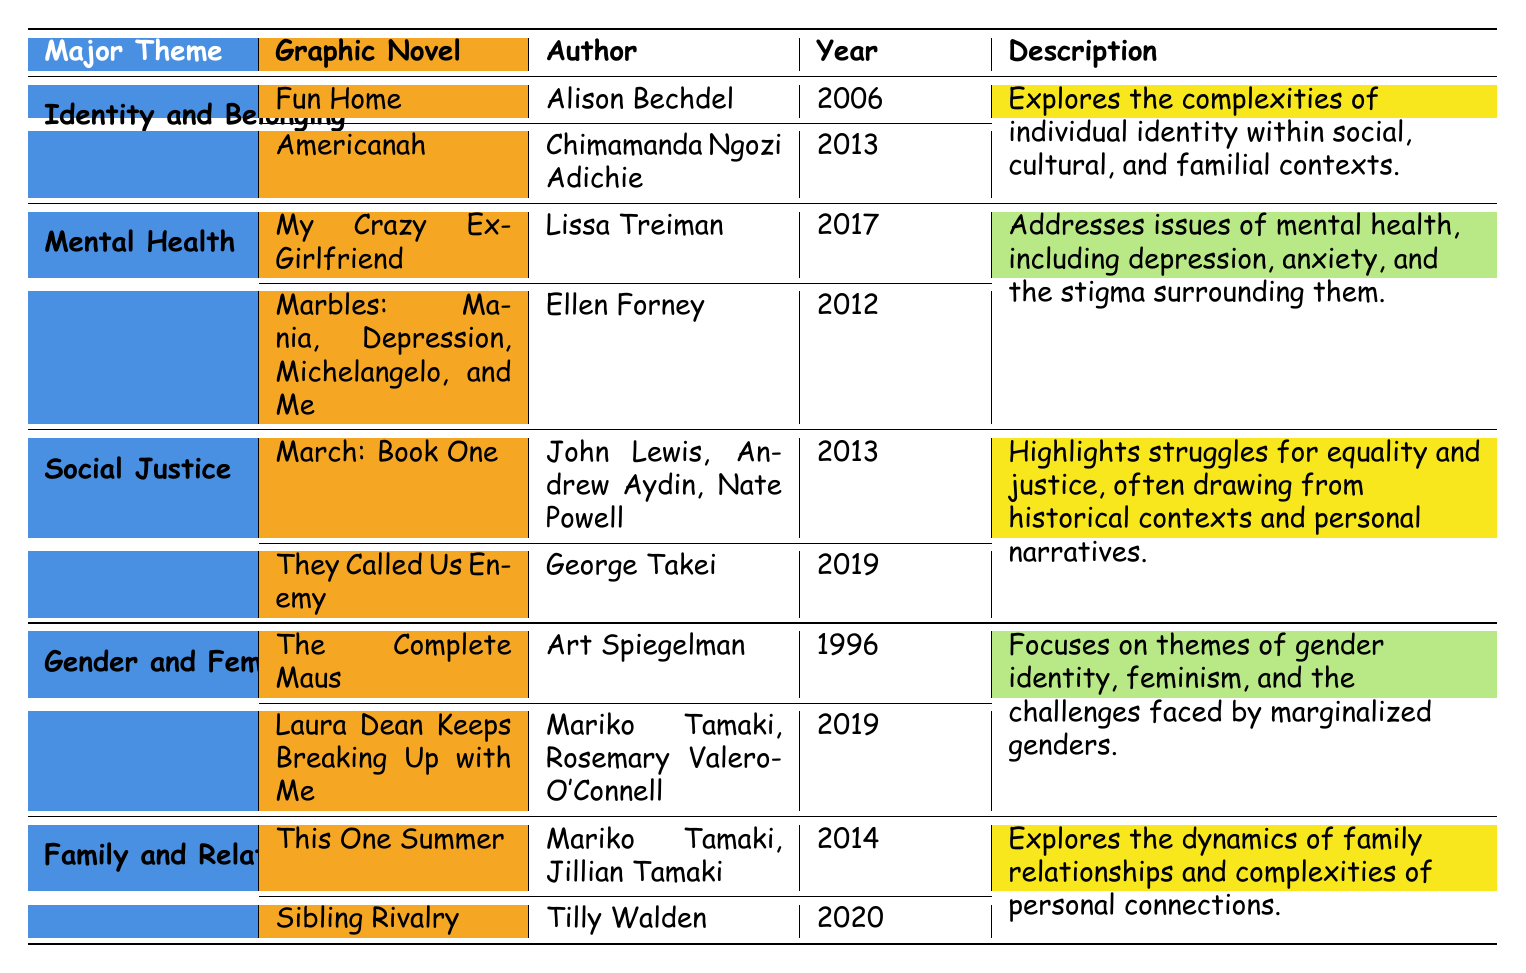What graphic novel focuses on identity and belonging? The table lists several graphic novels under the theme "Identity and Belonging," including "Fun Home" by Alison Bechdel and "Americanah" by Chimamanda Ngozi Adichie.
Answer: Fun Home, Americanah Which graphic novel was published in 2019? Scanning through the publication years in the table, "They Called Us Enemy" by George Takei and "Laura Dean Keeps Breaking Up with Me" by Mariko Tamaki and Rosemary Valero-O'Connell were both published in 2019.
Answer: They Called Us Enemy, Laura Dean Keeps Breaking Up with Me Is "March: Book One" associated with social justice? The table indicates that "March: Book One" is listed under the "Social Justice" theme, confirming its association.
Answer: Yes Which theme includes the graphic novel "Marbles: Mania, Depression, Michelangelo, and Me"? By looking at the table, "Marbles: Mania, Depression, Michelangelo, and Me" is grouped under the "Mental Health" theme.
Answer: Mental Health How many graphic novels are listed under the "Family and Relationships" theme? The table shows two graphic novels listed under "Family and Relationships": "This One Summer" and "Sibling Rivalry." Therefore, the count is two.
Answer: 2 What themes are explored by graphic novels published after 2013? Checking the publication years of graphic novels in the table, "Americanah" (2013), "My Crazy Ex-Girlfriend" (2017), "They Called Us Enemy" (2019), "Laura Dean Keeps Breaking Up with Me" (2019), and "Sibling Rivalry" (2020) relate to the themes of Identity and Belonging, Mental Health, Social Justice, Gender and Feminism, and Family and Relationships.
Answer: 5 themes Which theme has a description about stigma surrounding mental health? The table contains a description of the "Mental Health" theme that mentions stigma, confirming its focus on this aspect.
Answer: Mental Health What is the primary focus of the "Gender and Feminism" theme? The description in the table specifies that this theme focuses on gender identity, feminism, and the challenges faced by marginalized genders.
Answer: Gender identity and feminism Which author wrote a graphic novel about family dynamics published in 2014? Referring to the table, "This One Summer" by Mariko Tamaki and Jillian Tamaki is the graphic novel about family dynamics published in 2014.
Answer: Mariko Tamaki, Jillian Tamaki How many graphic novels are categorized under social justice, and what are their publication years? The table shows two graphic novels under "Social Justice": "March: Book One" (2013) and "They Called Us Enemy" (2019), totaling two graphic novels.
Answer: 2 graphic novels (2013, 2019) 